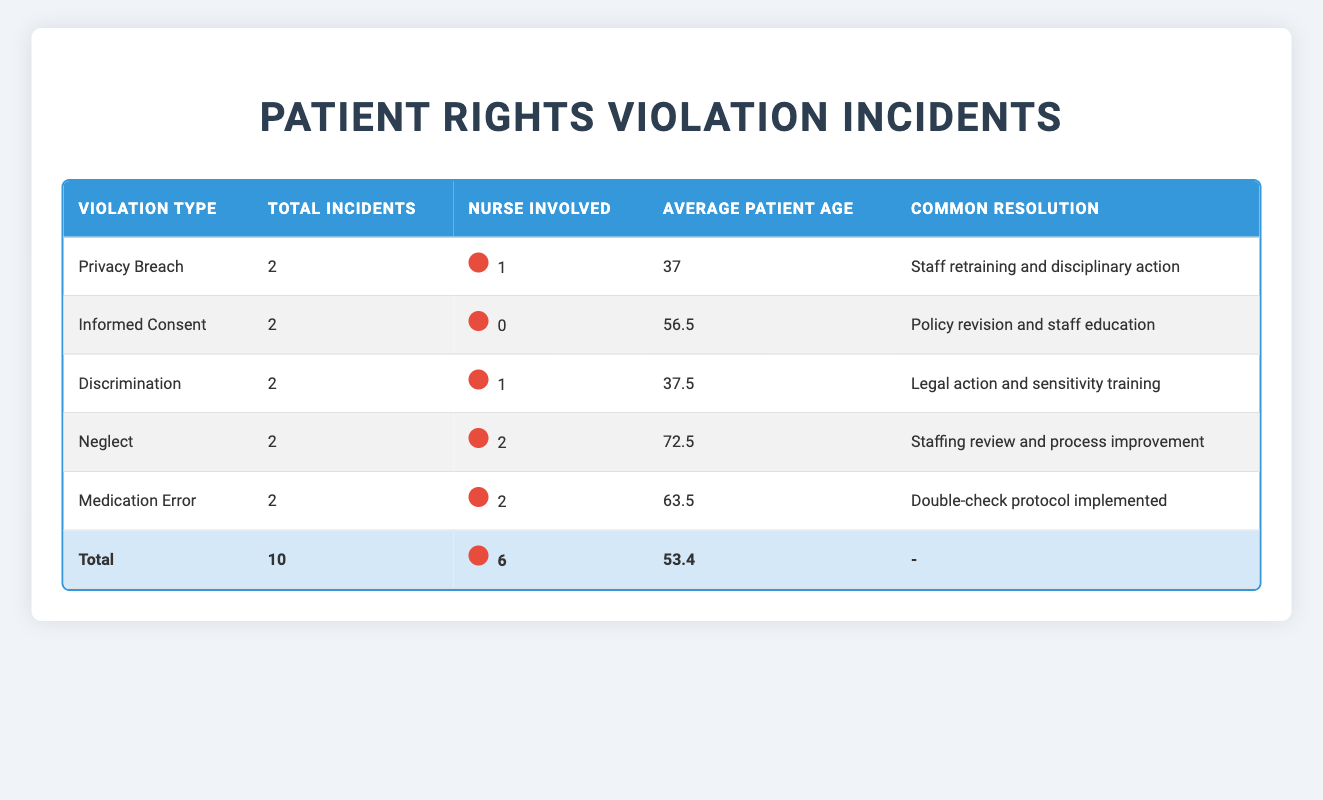What is the total number of incidents reported? By checking the "Total Incidents" row in the table, we find that it sums up to 10 across all violation types.
Answer: 10 Which violation type had the highest average patient age? For each violation type, we look at the "Average Patient Age" column: Neglect (72.5), Medication Error (63.5), Informed Consent (56.5), Discrimination (37.5), and Privacy Breach (37). The highest average age is 72.5 for Neglect.
Answer: Neglect Was a nurse involved in all incidents of discrimination? By reviewing the "Nurse Involved" column, we see that there were two discrimination incidents, and in one of them, a nurse was involved. Therefore, not all incidents had a nurse involved.
Answer: No How many incidents had staff retraining as a resolution? Looking at the "Common Resolution" column, we can identify the occurrences of "Staff retraining..." This appears in the rows for Privacy Breach, Neglect, and the second incident of Neglect, totaling 3 instances.
Answer: 3 What is the difference in total incident counts between Privacy Breach and Medication Error? From the table, Privacy Breach has 2 incidents, and Medication Error also has 2 incidents. The difference in counts is 2 - 2 = 0.
Answer: 0 How many incidents involved nurses in total? We count the rows where "Nurse Involved" is indicated with a nurse icon. There are 6 incidents with nurses involved, as shown in the table.
Answer: 6 Which violation type has no nurse involved in its incidents? Referring to the "Nurse Involved" column, we see that Informed Consent and Discrimination show zero involvement of nurses. Thus, Informed Consent is a violation type with no nurse involved.
Answer: Informed Consent What is the average age of patients involved in incidents where nurses were not involved? We look at the "Average Patient Age" of categories where "Nurse Involved" is marked as No: Informed Consent (56.5) and Discrimination (42). The average is (56.5 + 42) / 2 = 49.25.
Answer: 49.25 